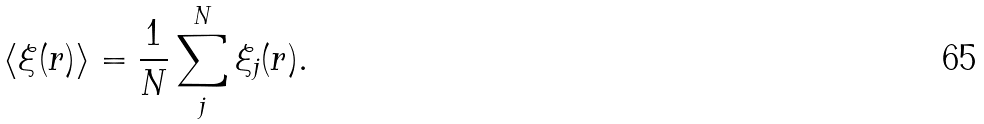<formula> <loc_0><loc_0><loc_500><loc_500>\langle \xi ( r ) \rangle = \frac { 1 } { N } \sum _ { j } ^ { N } \xi _ { j } ( r ) .</formula> 